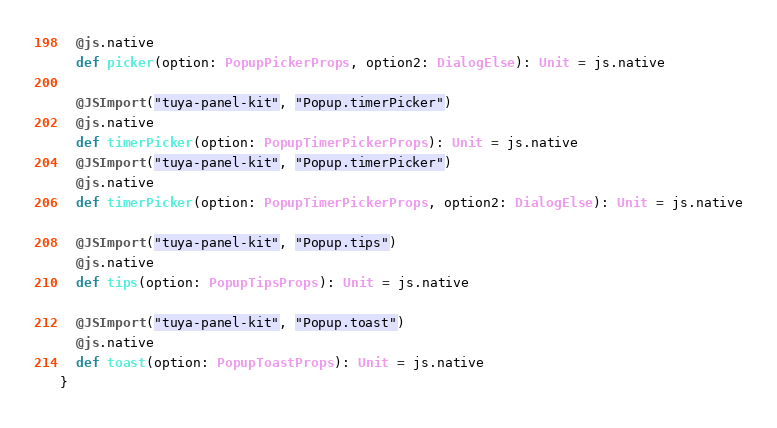Convert code to text. <code><loc_0><loc_0><loc_500><loc_500><_Scala_>  @js.native
  def picker(option: PopupPickerProps, option2: DialogElse): Unit = js.native
  
  @JSImport("tuya-panel-kit", "Popup.timerPicker")
  @js.native
  def timerPicker(option: PopupTimerPickerProps): Unit = js.native
  @JSImport("tuya-panel-kit", "Popup.timerPicker")
  @js.native
  def timerPicker(option: PopupTimerPickerProps, option2: DialogElse): Unit = js.native
  
  @JSImport("tuya-panel-kit", "Popup.tips")
  @js.native
  def tips(option: PopupTipsProps): Unit = js.native
  
  @JSImport("tuya-panel-kit", "Popup.toast")
  @js.native
  def toast(option: PopupToastProps): Unit = js.native
}
</code> 